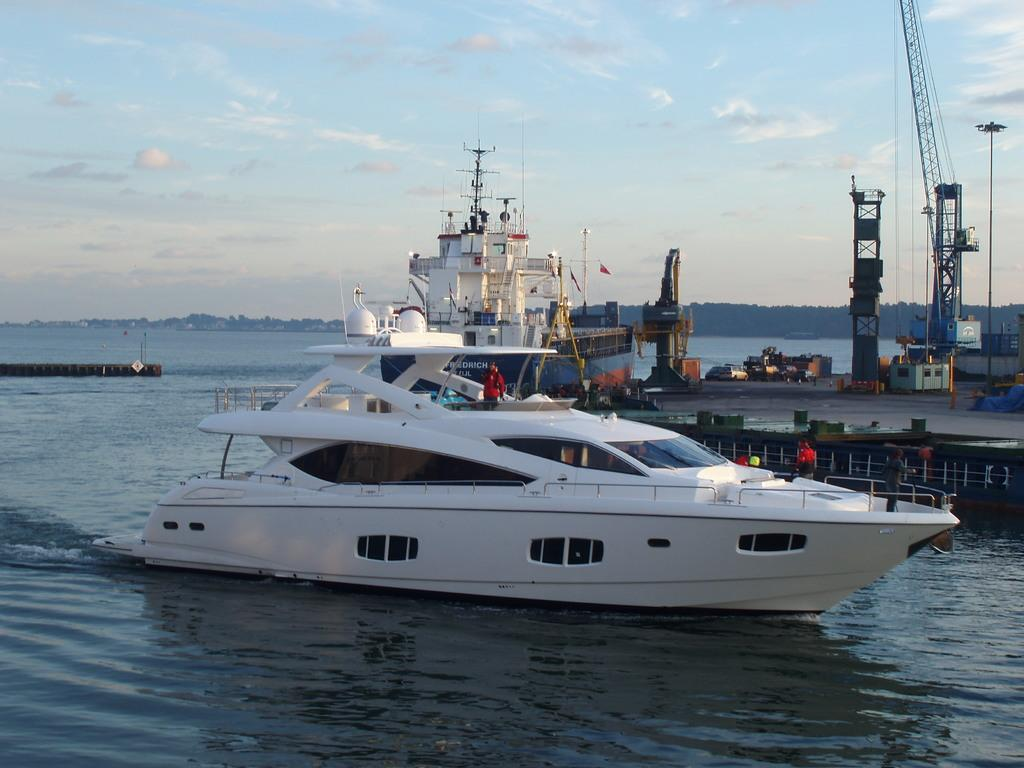What types of watercraft are in the image? There are boats and ships in the image. Where are the boats and ships located? The boats and ships are on the water. What type of equipment is visible in the image? There is a crane visible in the image. What other types of vehicles can be seen in the image? There are vehicles in the image. What can be seen in the background of the image? There are trees, clouds, and the sky visible in the background of the image. How many spiders are crawling on the boats in the image? There are no spiders visible in the image; it features boats and ships on the water. Can you tell me how many people are swimming in the water near the boats? There is no indication of anyone swimming in the water near the boats in the image. 